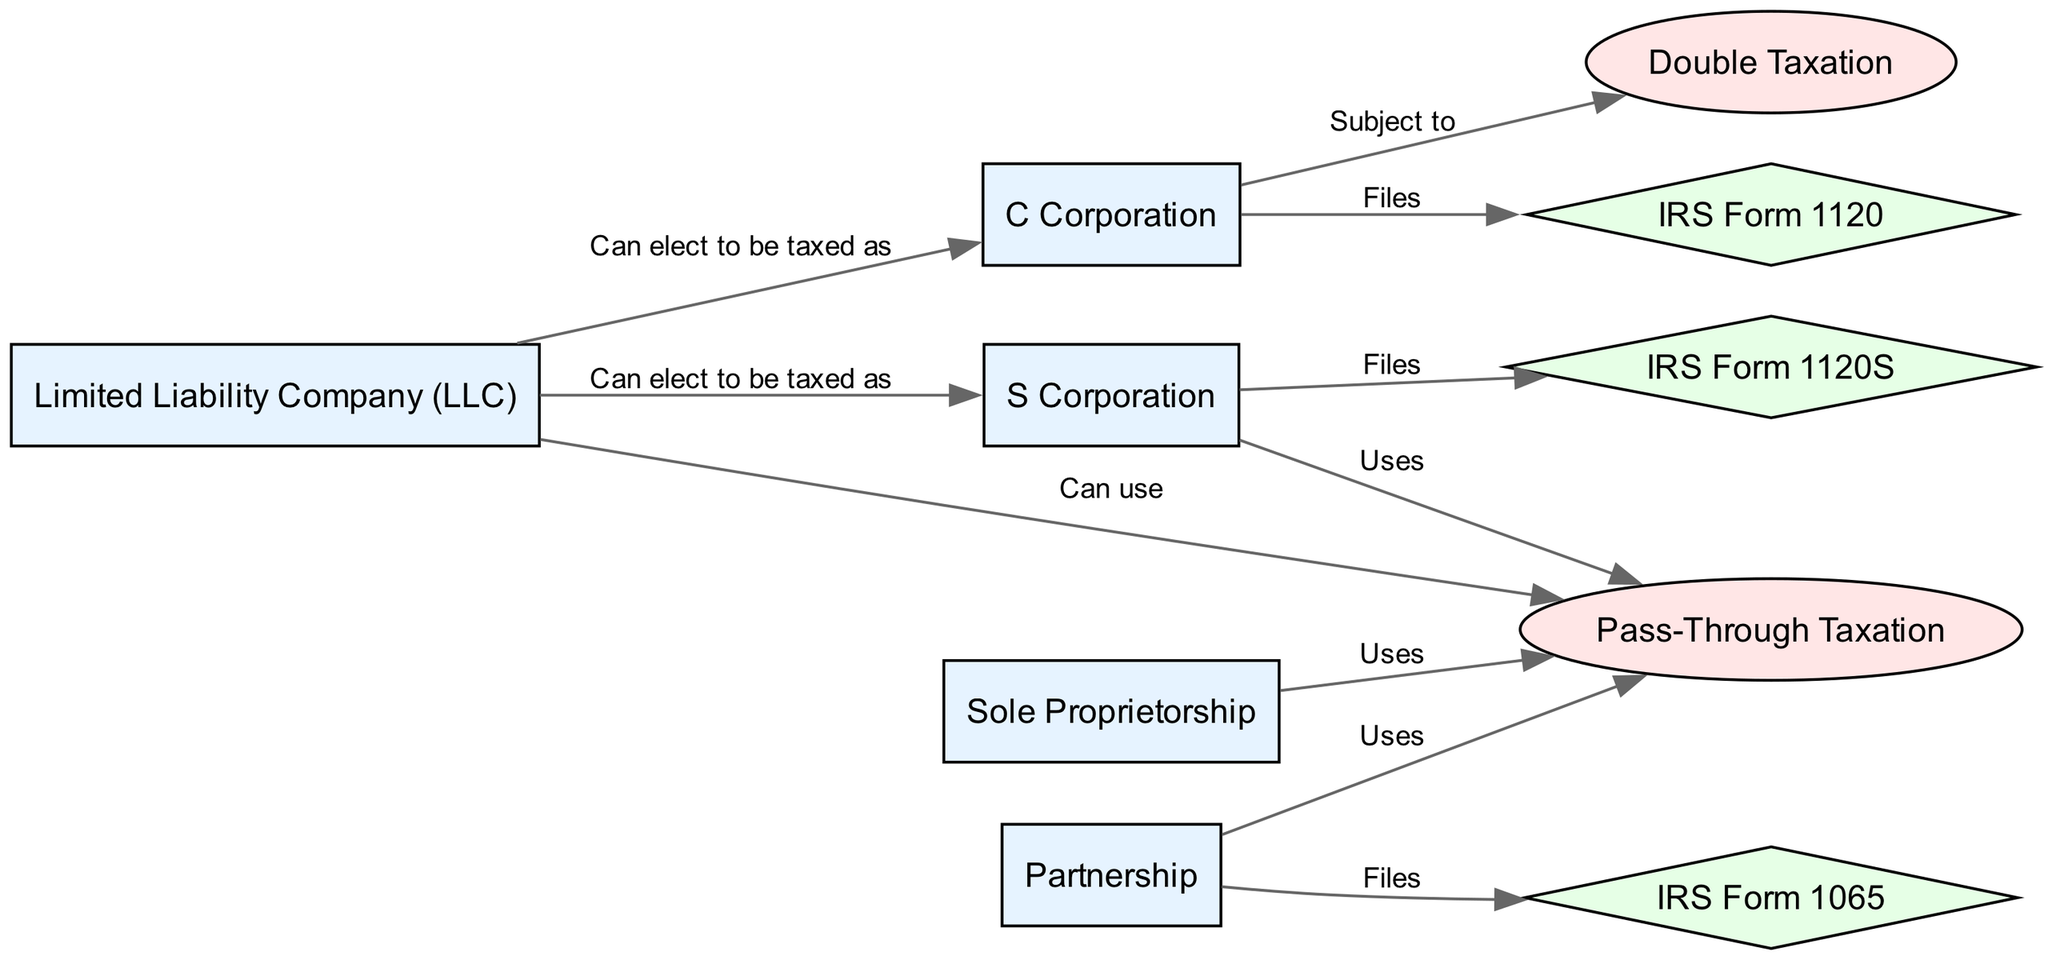What business entity is subject to double taxation? In the diagram, the edge labeled "Subject to" connects "C Corporation" to "Double Taxation". This indicates that a C Corporation is specifically subject to this taxation method.
Answer: C Corporation Which form does an S Corporation file? From the diagram, the edge labeled "Files" connects "S Corporation" to "IRS Form 1120S", indicating that this is the form associated with an S Corporation.
Answer: IRS Form 1120S How many nodes represent business entities in the diagram? By counting the nodes labeled with business entities such as C Corporation, S Corporation, Partnership, LLC, and Sole Proprietorship, we find there are five distinct business entity nodes in total.
Answer: 5 What type of taxation does a Partnership use? The diagram shows that a Partnership has an edge labeled "Uses" pointing to "Pass-Through Taxation," indicating that this is the type of taxation a Partnership uses.
Answer: Pass-Through Taxation Which two entities can elect to be taxed as an S Corporation? Following the diagram, the edges show that both "Limited Liability Company (LLC)" and "C Corporation" have edges labeled "Can elect to be taxed as" pointing to "S Corporation," which means both entities have this option.
Answer: Limited Liability Company, C Corporation What form do Partnerships use for tax filing? According to the diagram, the edge labeled "Files" connects "Partnership" to "IRS Form 1065," showing that this is the form used for tax filing by Partnerships.
Answer: IRS Form 1065 What connection is implied between Limited Liability Companies and taxation? The diagram indicates there is an edge labeled "Can use" connecting "Limited Liability Company (LLC)" to "Pass-Through Taxation," which implies that LLCs have the ability to use this type of taxation.
Answer: Can use Pass-Through Taxation How many edges connect business entities to their taxation methods in the diagram? By counting the edges in the diagram that connect business entities to their taxation types, we find there are seven such connections that represent these relationships.
Answer: 7 What taxation type does a Sole Proprietorship use? The diagram shows that the edge labeled "Uses" connects "Sole Proprietorship" to "Pass-Through Taxation," which specifies that Sole Proprietorships use this type of taxation.
Answer: Pass-Through Taxation 